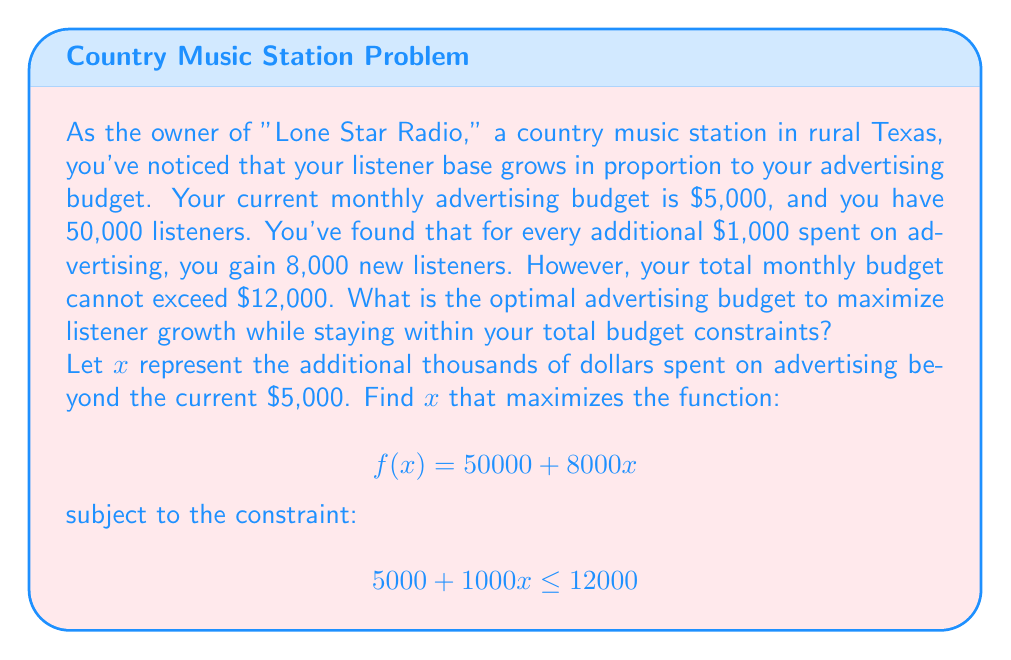Solve this math problem. Let's approach this step-by-step:

1) First, we need to determine the domain of $x$ based on the budget constraint:
   
   $5000 + 1000x \leq 12000$
   $1000x \leq 7000$
   $x \leq 7$

   Since $x$ represents thousands of dollars, it must also be non-negative. So, $0 \leq x \leq 7$.

2) Now, let's look at the function we want to maximize:
   
   $f(x) = 50000 + 8000x$

   This is a linear function, and linear functions always reach their maximum value at one of the endpoints of their domain (unless they're constant).

3) Let's evaluate $f(x)$ at both endpoints:

   At $x = 0$: $f(0) = 50000 + 8000(0) = 50000$
   At $x = 7$: $f(7) = 50000 + 8000(7) = 106000$

4) Clearly, $f(7)$ is larger, so the optimal solution is to spend an additional $7,000 on advertising.

5) This means the total optimal advertising budget is:
   
   $5000 + 7000 = 12000$

6) At this budget, the number of listeners would be:
   
   $50000 + 8000(7) = 106000$
Answer: The optimal advertising budget is $12,000, which would result in 106,000 listeners. 